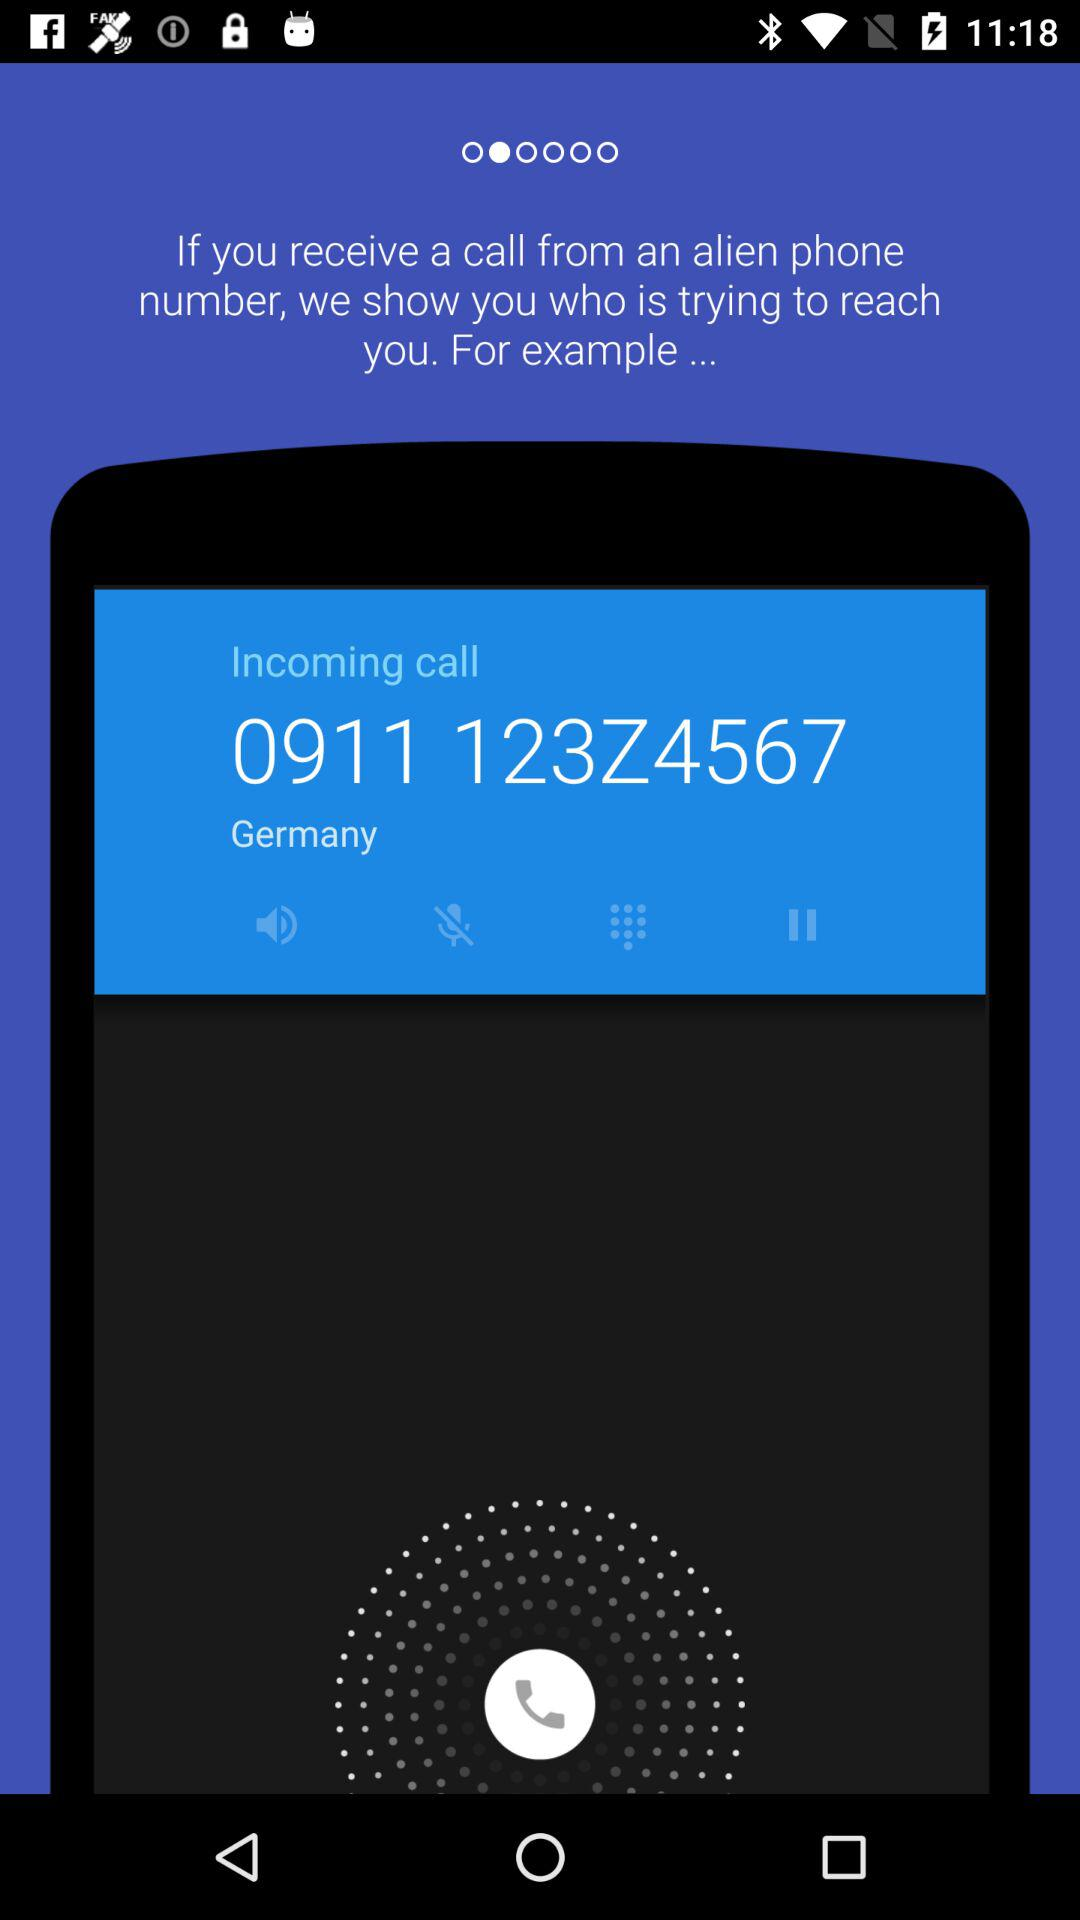What country is the phone number from? The country is Germany. 